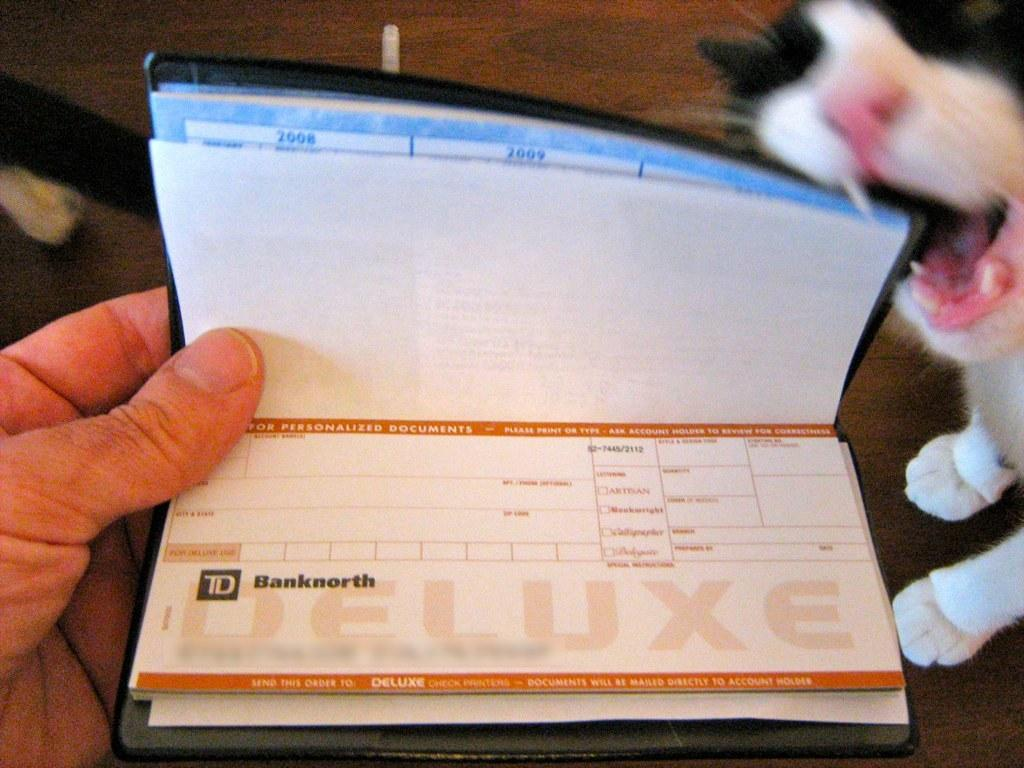What is the person holding in the image? There is a person's hand holding a book in the image. What type of animal can be seen in the image? There is a cat visible in the image. What is the primary setting of the image? The background of the image includes the floor. What route is the person taking with the cat in the image? There is no indication of a route or travel in the image; it simply shows a person's hand holding a book and a cat visible in the background. How many feet can be seen in the image? The image does not show any feet; it only shows a person's hand holding a book and a cat in the background. 